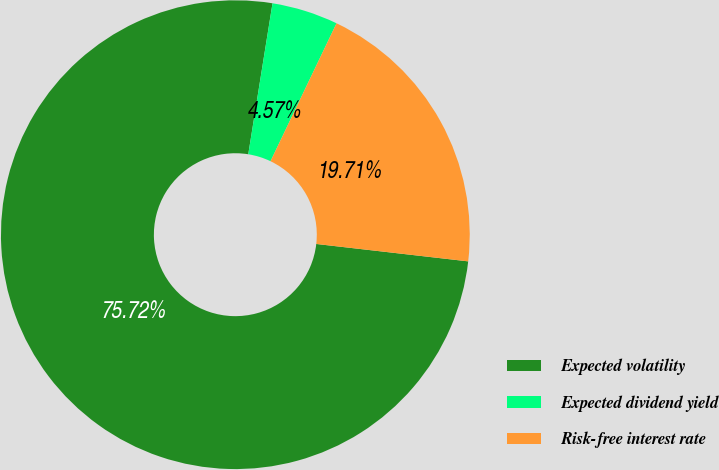Convert chart. <chart><loc_0><loc_0><loc_500><loc_500><pie_chart><fcel>Expected volatility<fcel>Expected dividend yield<fcel>Risk-free interest rate<nl><fcel>75.72%<fcel>4.57%<fcel>19.71%<nl></chart> 